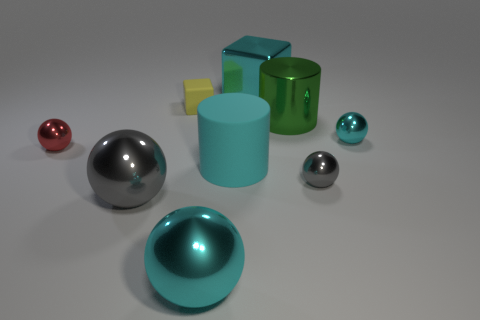What number of big metal balls have the same color as the large rubber object?
Your answer should be compact. 1. There is a large rubber object; is it the same color as the shiny thing that is behind the yellow object?
Your answer should be very brief. Yes. Are there fewer big cylinders than rubber balls?
Make the answer very short. No. Are there more small yellow matte blocks to the left of the green cylinder than large cylinders that are in front of the small gray metal sphere?
Offer a very short reply. Yes. Is the cyan block made of the same material as the small yellow thing?
Give a very brief answer. No. How many cyan balls are behind the cyan metallic object behind the yellow object?
Make the answer very short. 0. Does the cylinder that is on the left side of the big cyan block have the same color as the big cube?
Give a very brief answer. Yes. What number of things are either tiny blocks or large cyan objects behind the big green object?
Offer a terse response. 2. There is a small red thing that is in front of the large metallic cylinder; does it have the same shape as the gray object that is right of the metallic cylinder?
Keep it short and to the point. Yes. Is there anything else of the same color as the metallic cylinder?
Your answer should be compact. No. 